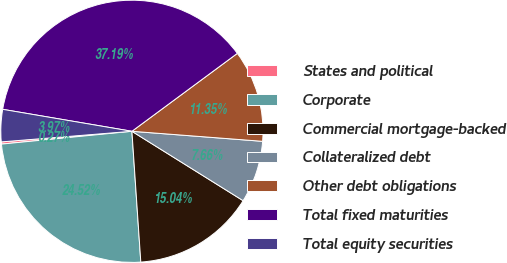Convert chart to OTSL. <chart><loc_0><loc_0><loc_500><loc_500><pie_chart><fcel>States and political<fcel>Corporate<fcel>Commercial mortgage-backed<fcel>Collateralized debt<fcel>Other debt obligations<fcel>Total fixed maturities<fcel>Total equity securities<nl><fcel>0.27%<fcel>24.52%<fcel>15.04%<fcel>7.66%<fcel>11.35%<fcel>37.19%<fcel>3.97%<nl></chart> 